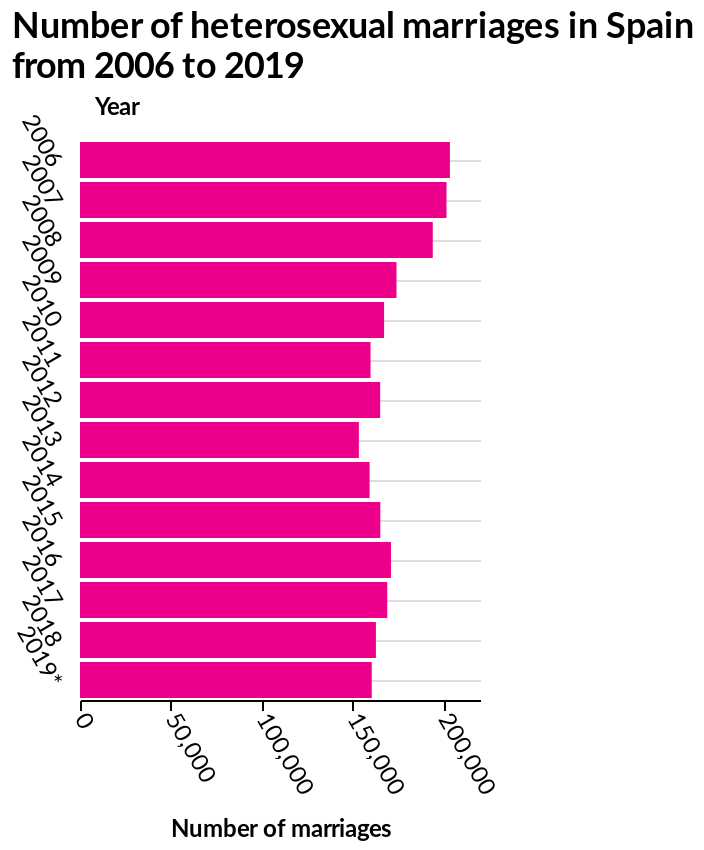<image>
Describe the following image in detail Number of heterosexual marriages in Spain from 2006 to 2019 is a bar chart. The y-axis measures Year while the x-axis plots Number of marriages. What does the y-axis measure in the bar chart representing the number of heterosexual marriages in Spain from 2006 to 2019?  The y-axis of the bar chart measures the years from 2006 to 2019. 